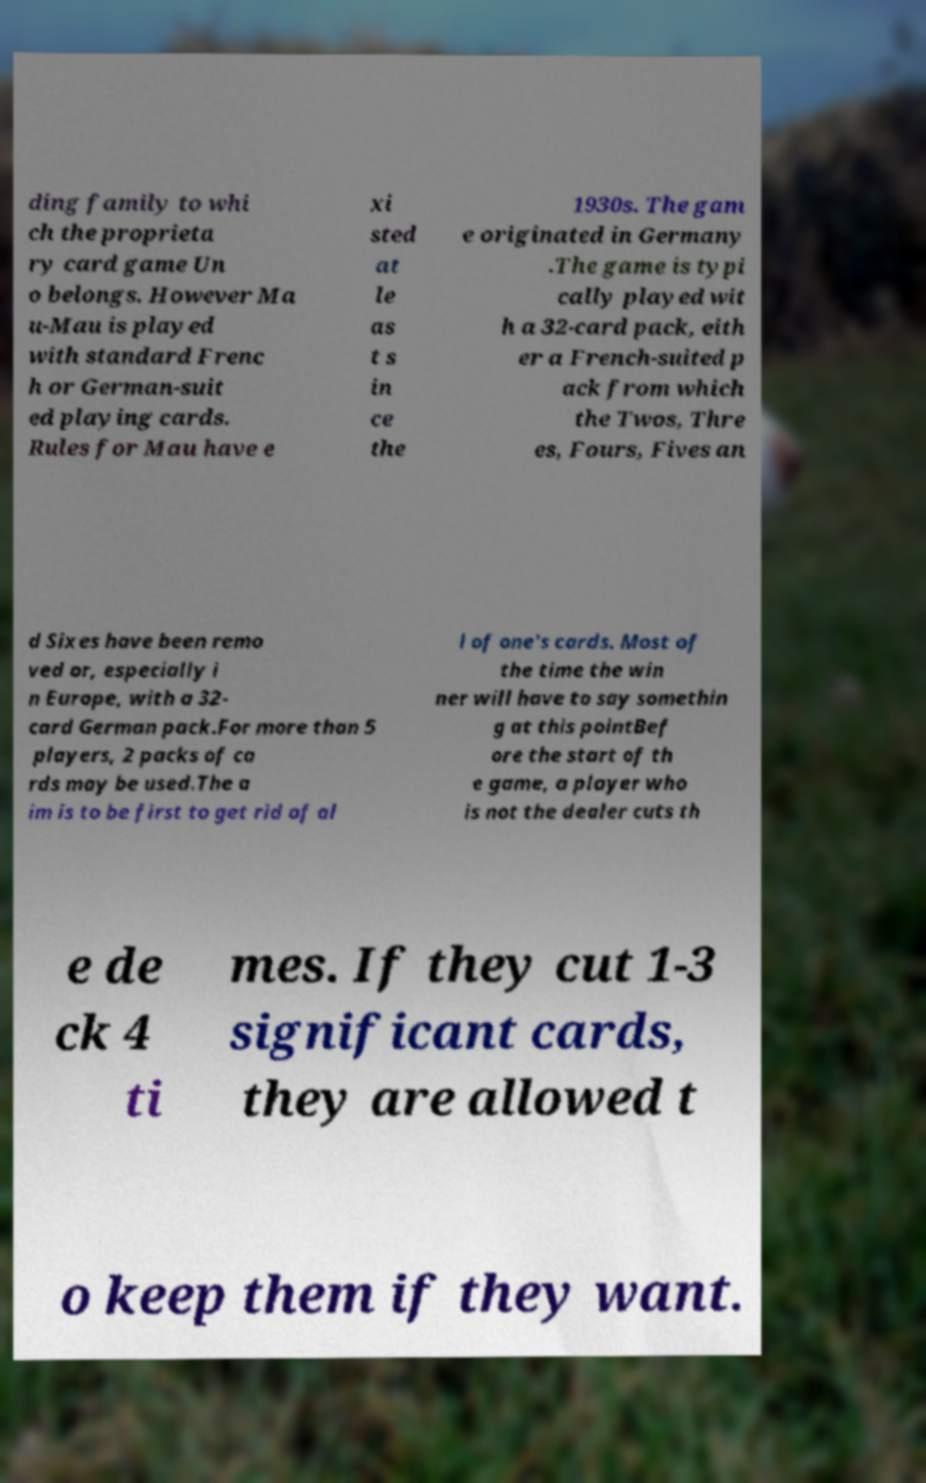Please read and relay the text visible in this image. What does it say? ding family to whi ch the proprieta ry card game Un o belongs. However Ma u-Mau is played with standard Frenc h or German-suit ed playing cards. Rules for Mau have e xi sted at le as t s in ce the 1930s. The gam e originated in Germany .The game is typi cally played wit h a 32-card pack, eith er a French-suited p ack from which the Twos, Thre es, Fours, Fives an d Sixes have been remo ved or, especially i n Europe, with a 32- card German pack.For more than 5 players, 2 packs of ca rds may be used.The a im is to be first to get rid of al l of one's cards. Most of the time the win ner will have to say somethin g at this pointBef ore the start of th e game, a player who is not the dealer cuts th e de ck 4 ti mes. If they cut 1-3 significant cards, they are allowed t o keep them if they want. 